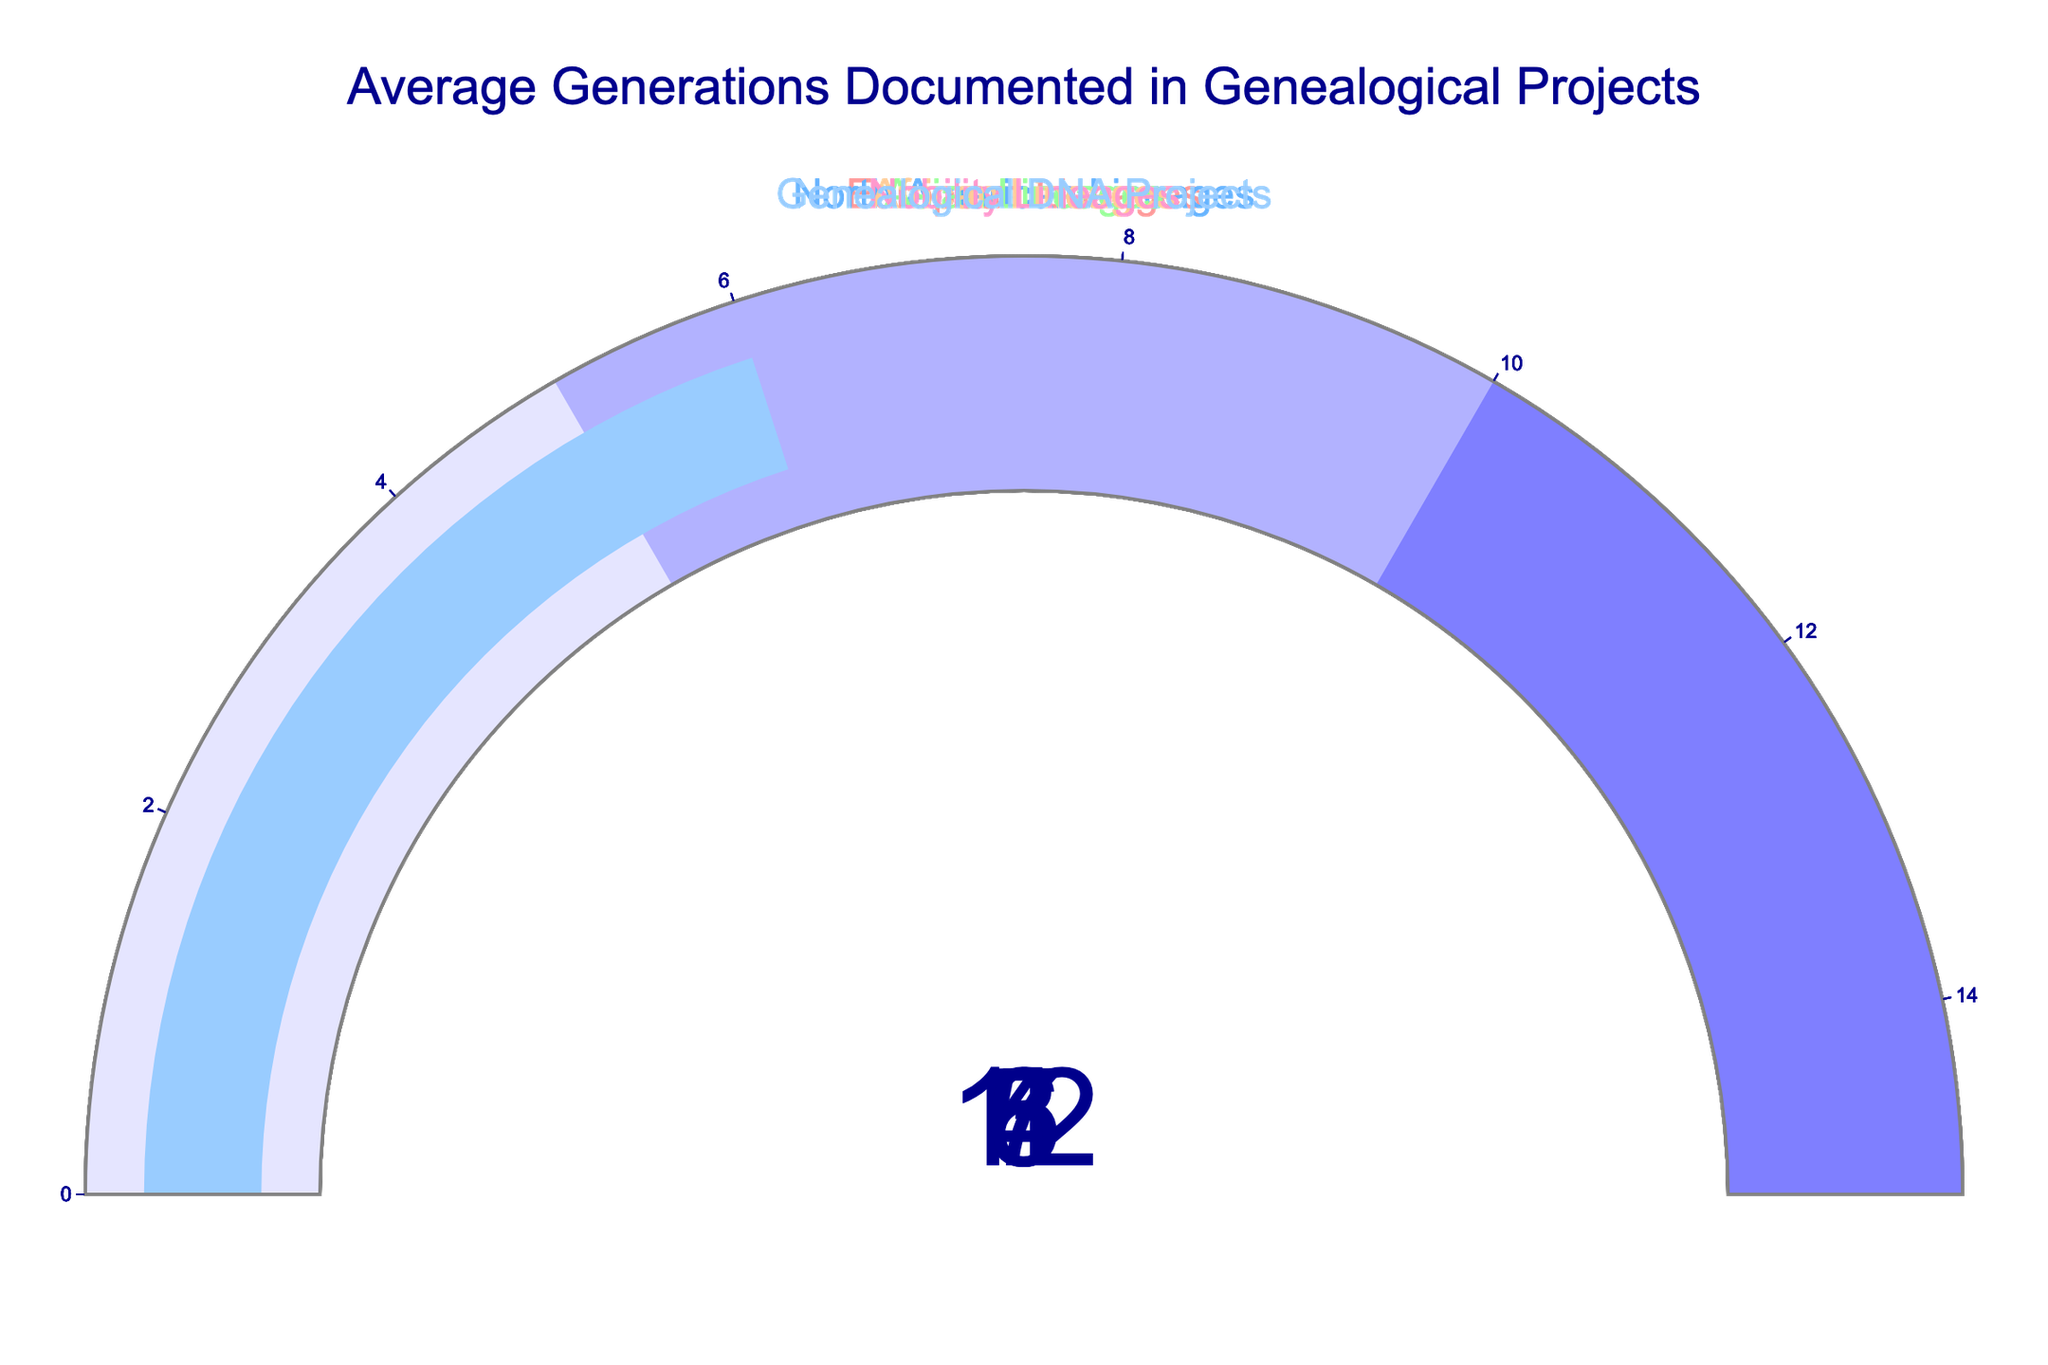What's the highest average number of generations documented for any lineage? The highest average number of generations documented is shown in the gauge for Nobility Lineages. This gauge displays the value '12'.
Answer: 12 Which lineage has the lowest average number of generations documented? The lowest average number of generations documented is for African Lineages, where the gauge displays the value '3'.
Answer: African Lineages Compare European Lineages and North American Lineages. Which has a higher average number of generations documented, and by how much? European Lineages have an average of 7 generations documented, while North American Lineages have an average of 5 generations documented. Therefore, European Lineages have 2 more generations documented on average than North American Lineages.
Answer: European Lineages, 2 generations What is the total average number of generations documented for Asian Lineages and Genealogical DNA Projects combined? Asian Lineages have an average of 4 generations, and Genealogical DNA Projects have an average of 6 generations. Summing these two values, 4 + 6, we get 10.
Answer: 10 What is the median value of the average number of generations documented across all lineages? To find the median, we first list all the averages: [7, 5, 4, 3, 12, 6]. When ordered, this becomes [3, 4, 5, 6, 7, 12]. The median is the average of the two middle values, (5 + 6)/2 = 5.5.
Answer: 5.5 What is the visual indication of highly documented lineages on the gauges? The gauges with higher average numbers are closer to the right and use colors in the pink to blue spectrum (e.g., European Lineages has pink, and Nobility Lineages has light blue). The value on these gauges is also higher.
Answer: Pink to blue spectrum, higher values By how much does the documented average number of generations for Nobility Lineages exceed that of African Lineages? Nobility Lineages have 12 generations documented on average, and African Lineages have 3. The difference is 12 - 3 = 9.
Answer: 9 Which documented lineages fall within the range of 4 to 6 generations on average? The lineages within this range are Asian Lineages (4), North American Lineages (5), and Genealogical DNA Projects (6).
Answer: Asian Lineages, North American Lineages, Genealogical DNA Projects 